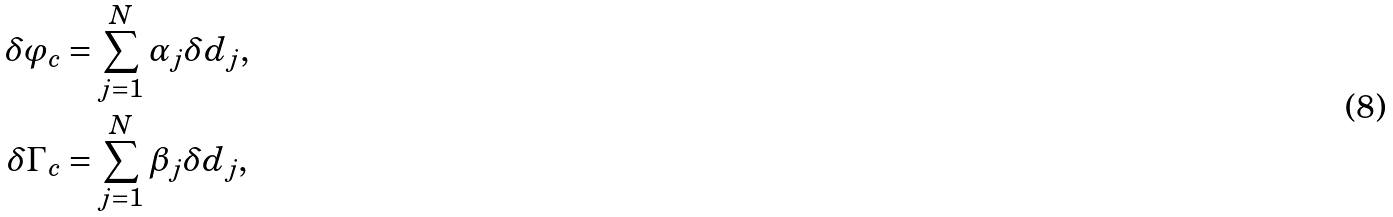<formula> <loc_0><loc_0><loc_500><loc_500>\delta \varphi _ { c } & = \sum _ { j = 1 } ^ { N } \alpha _ { j } \delta d _ { j } , \\ \delta \Gamma _ { c } & = \sum _ { j = 1 } ^ { N } \beta _ { j } \delta d _ { j } ,</formula> 